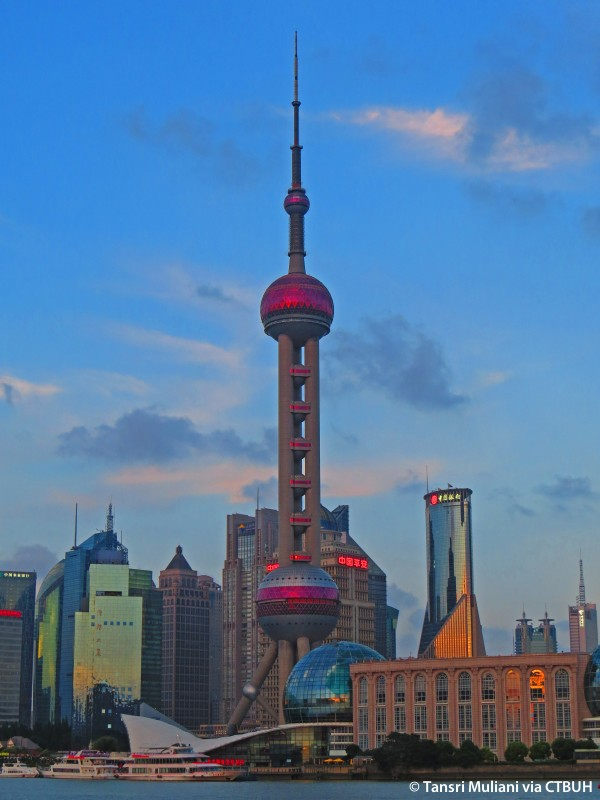Can you describe the architectural style of the Oriental Pearl Tower and its surroundings? The architectural style of the Oriental Pearl Tower is a blend of futuristic and modern design, highlighted by its unique shape and the use of glass and steel. The tower's structure consists of a series of spheres supported by cylindrical columns, giving it a distinct and avant-garde appearance. This futuristic design contrasts with the more traditional modern skyscrapers surrounding it, which are characterized by sleek lines and reflective glass facades. The juxtaposition of these architectural styles creates a dynamic and visually interesting cityscape that represents Shanghai's blend of tradition and innovation. What role does the Oriental Pearl Tower play in the cultural and social life of Shanghai? The Oriental Pearl Tower is not only an architectural marvel but also a cultural and social hub in Shanghai. It houses several observation decks that offer spectacular views of the city, attracting both locals and tourists. Inside the tower, there are restaurants, a shopping mall, a museum dedicated to the development of Shanghai, and even a hotel. The tower often serves as a venue for cultural events, exhibitions, and festivities, making it a focal point for the city's social life. Its iconic status has also made it a symbol of Shanghai's rapid modernization and economic growth. 